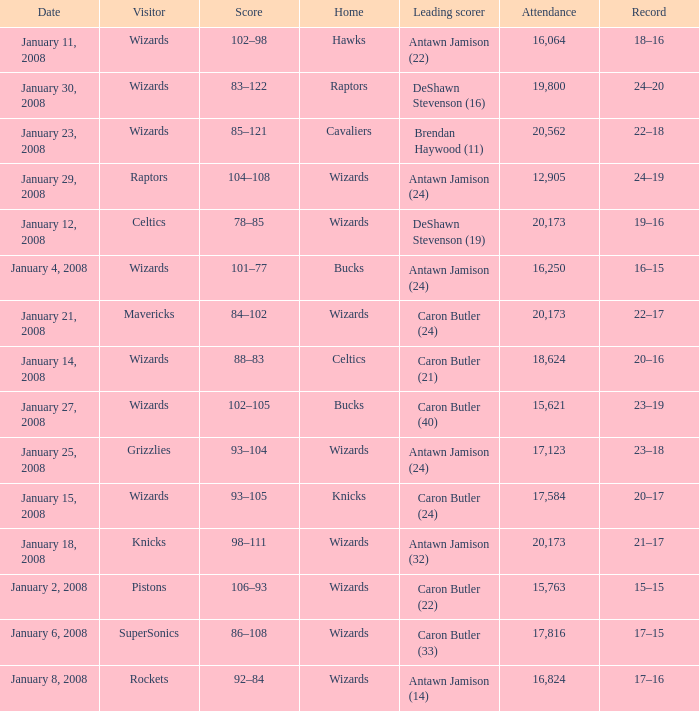What is the record when the leading scorer is Antawn Jamison (14)? 17–16. 